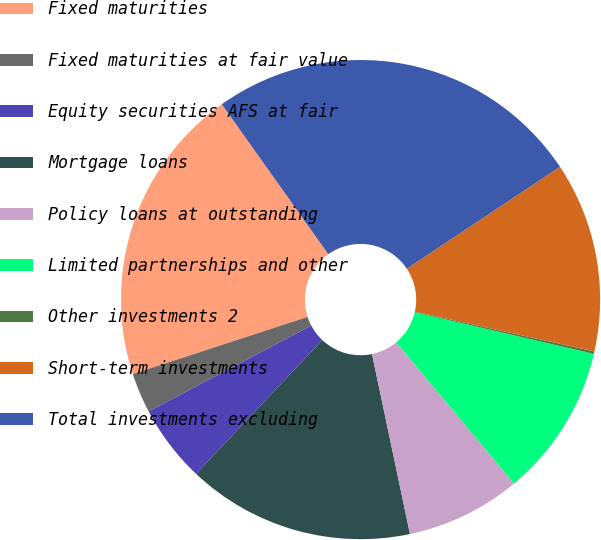<chart> <loc_0><loc_0><loc_500><loc_500><pie_chart><fcel>Fixed maturities<fcel>Fixed maturities at fair value<fcel>Equity securities AFS at fair<fcel>Mortgage loans<fcel>Policy loans at outstanding<fcel>Limited partnerships and other<fcel>Other investments 2<fcel>Short-term investments<fcel>Total investments excluding<nl><fcel>20.2%<fcel>2.7%<fcel>5.23%<fcel>15.35%<fcel>7.76%<fcel>10.29%<fcel>0.17%<fcel>12.82%<fcel>25.48%<nl></chart> 